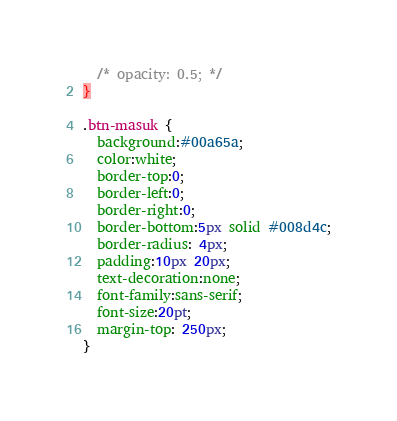<code> <loc_0><loc_0><loc_500><loc_500><_CSS_>  /* opacity: 0.5; */
}

.btn-masuk {
  background:#00a65a;
  color:white;
  border-top:0;
  border-left:0;
  border-right:0;
  border-bottom:5px solid #008d4c;
  border-radius: 4px;
  padding:10px 20px;
  text-decoration:none;
  font-family:sans-serif;
  font-size:20pt;
  margin-top: 250px;
}
</code> 